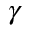<formula> <loc_0><loc_0><loc_500><loc_500>\gamma</formula> 